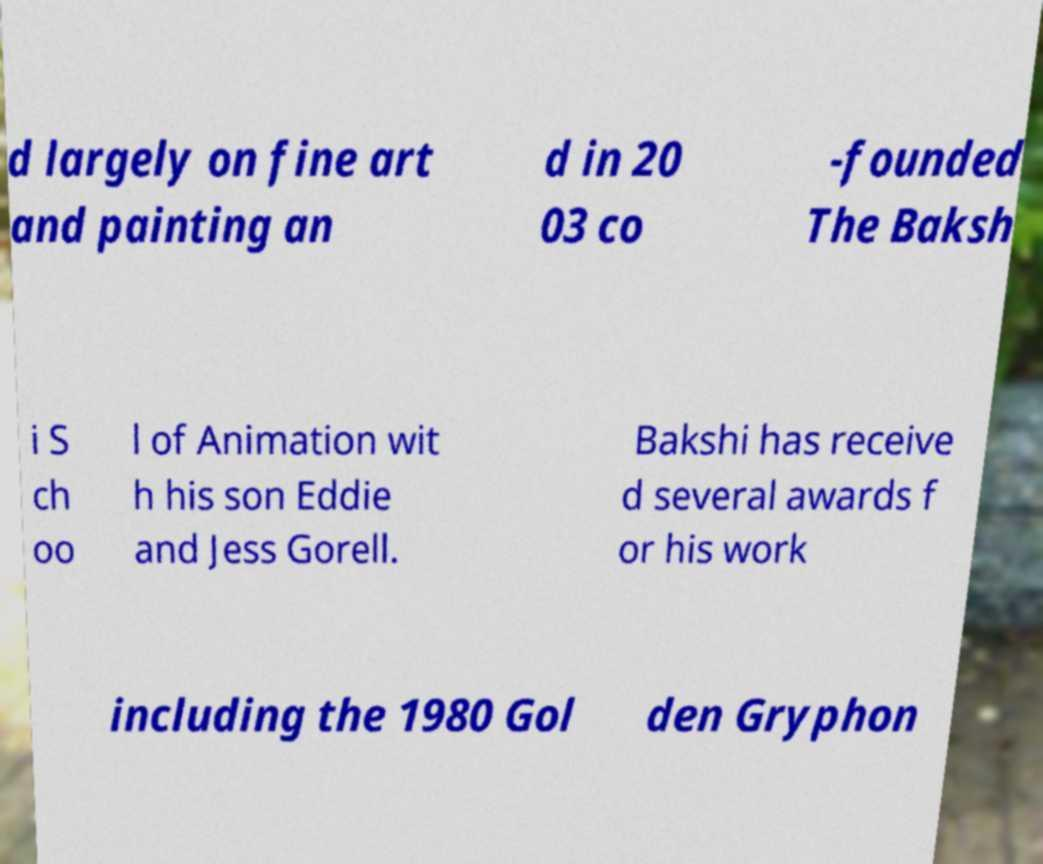What messages or text are displayed in this image? I need them in a readable, typed format. d largely on fine art and painting an d in 20 03 co -founded The Baksh i S ch oo l of Animation wit h his son Eddie and Jess Gorell. Bakshi has receive d several awards f or his work including the 1980 Gol den Gryphon 